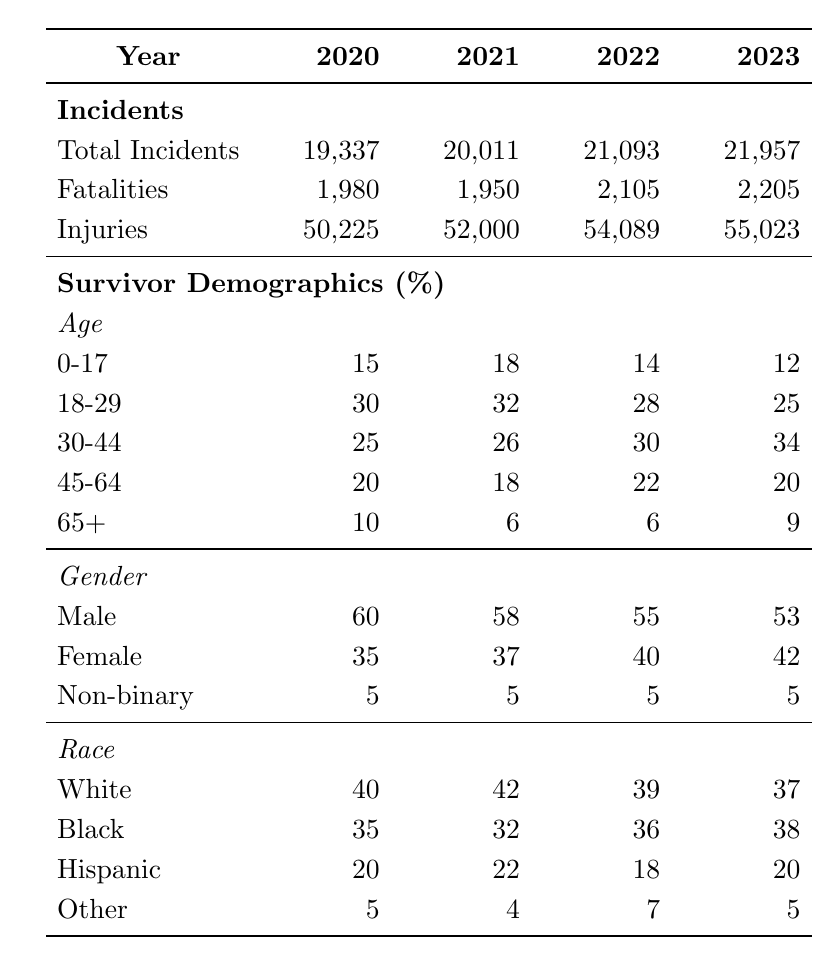What was the total number of gun violence incidents in 2022? In the table, under the "Total Incidents" row for 2022, the value is listed as 21,093.
Answer: 21,093 Which year had the highest number of fatalities? By comparing the "Fatalities" row across the years, 2023 has the highest value with 2,205 fatalities.
Answer: 2023 What percentage of gun violence survivors were female in 2021? Referring to the "Gender" section for 2021, the percentage of female survivors is 37%.
Answer: 37% What was the change in the percentage of survivors aged 0-17 from 2020 to 2023? The percentage of survivors aged 0-17 decreased from 15% in 2020 to 12% in 2023, representing a change of -3 percentage points.
Answer: -3 percentage points In which year did the percentage of Black survivors peak? From the "Race" section, the percentage of Black survivors reached its highest in 2023 at 38%.
Answer: 2023 What is the total number of fatalities across all four years? Adding the fatalities from each year: 1,980 + 1,950 + 2,105 + 2,205 gives a total of 8,240 fatalities.
Answer: 8,240 Was there an increase or decrease in the percentage of male survivors from 2020 to 2022? The percentage of male survivors decreased from 60% in 2020 to 55% in 2022, indicating a decrease.
Answer: Decrease How many total incidents were reported in 2021 compared to 2020? The number of incidents in 2021 is 20,011, and in 2020, it's 19,337. The difference is 20,011 - 19,337 = 674 more incidents in 2021.
Answer: 674 more incidents What is the average percentage of Hispanic survivors across these four years? Adding the percentage values (20 + 22 + 18 + 20) and dividing by 4 gives an average of 20%.
Answer: 20% Which age group increased in percentage the most from 2021 to 2022? Comparing the age percentages, the 30-44 age group increased from 26% in 2021 to 30% in 2022, a difference of +4 percentage points, which is the largest increase among age groups.
Answer: 30-44 age group 